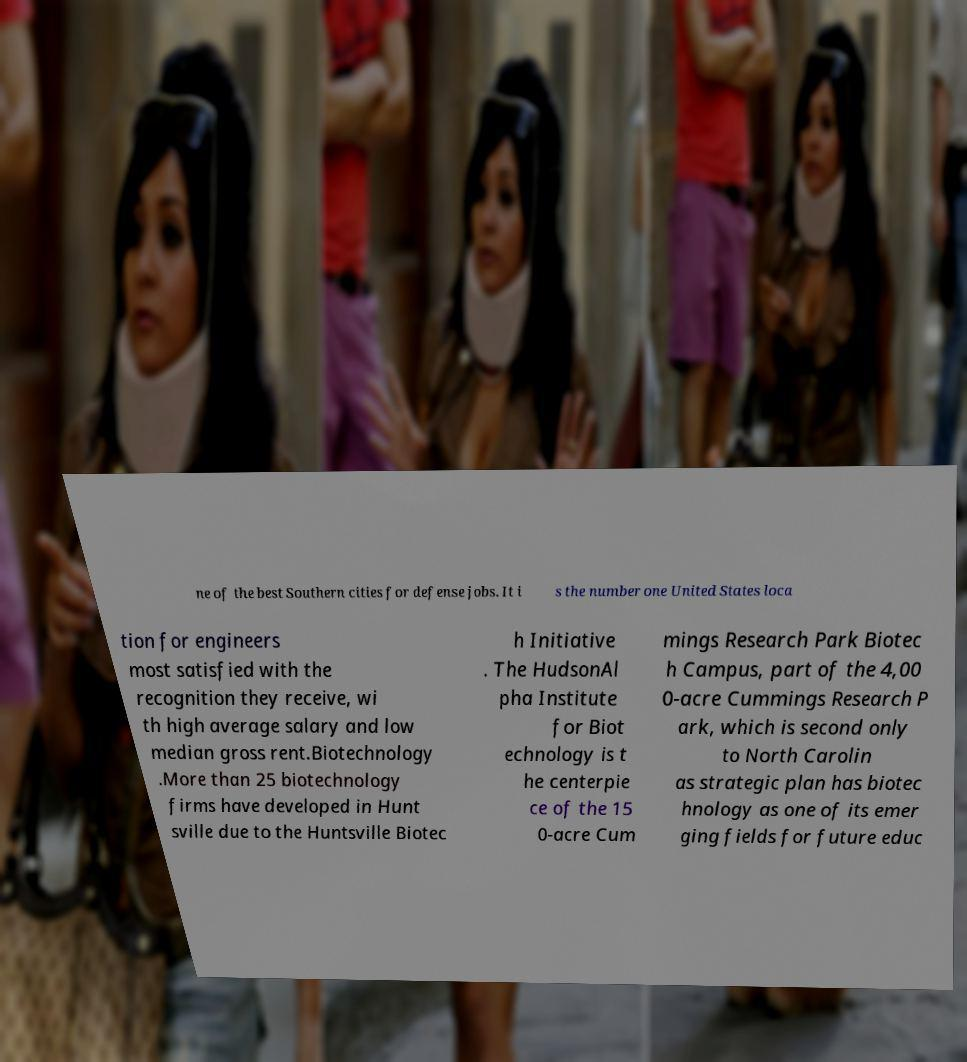I need the written content from this picture converted into text. Can you do that? ne of the best Southern cities for defense jobs. It i s the number one United States loca tion for engineers most satisfied with the recognition they receive, wi th high average salary and low median gross rent.Biotechnology .More than 25 biotechnology firms have developed in Hunt sville due to the Huntsville Biotec h Initiative . The HudsonAl pha Institute for Biot echnology is t he centerpie ce of the 15 0-acre Cum mings Research Park Biotec h Campus, part of the 4,00 0-acre Cummings Research P ark, which is second only to North Carolin as strategic plan has biotec hnology as one of its emer ging fields for future educ 